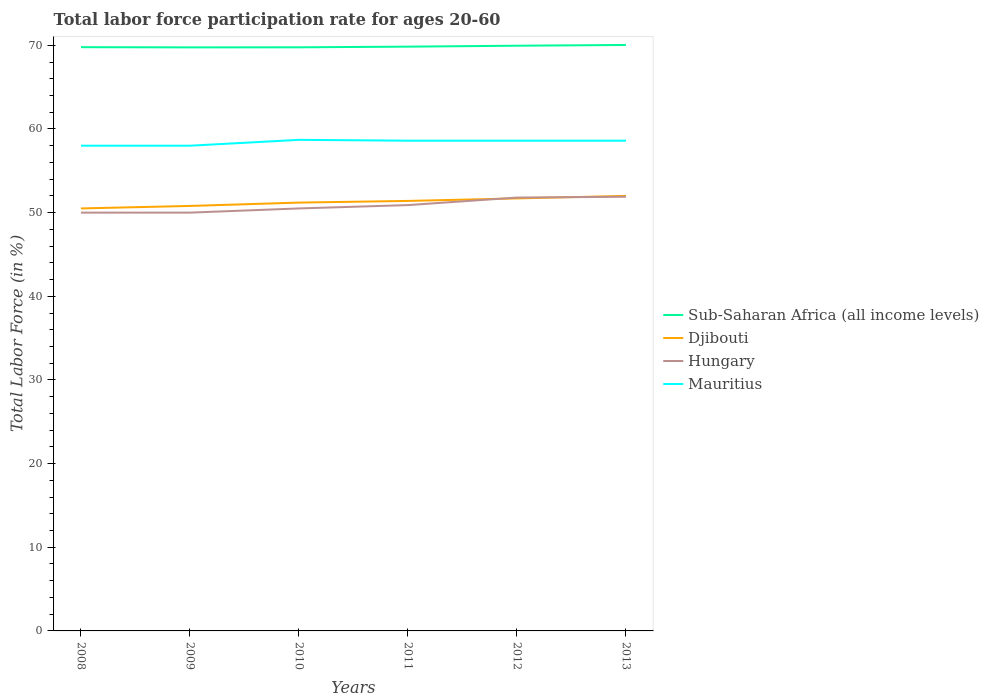How many different coloured lines are there?
Your answer should be compact. 4. Does the line corresponding to Mauritius intersect with the line corresponding to Hungary?
Give a very brief answer. No. Is the number of lines equal to the number of legend labels?
Provide a short and direct response. Yes. Across all years, what is the maximum labor force participation rate in Mauritius?
Give a very brief answer. 58. In which year was the labor force participation rate in Sub-Saharan Africa (all income levels) maximum?
Keep it short and to the point. 2009. What is the total labor force participation rate in Djibouti in the graph?
Provide a short and direct response. -0.6. What is the difference between the highest and the second highest labor force participation rate in Mauritius?
Provide a succinct answer. 0.7. What is the difference between the highest and the lowest labor force participation rate in Mauritius?
Ensure brevity in your answer.  4. How many lines are there?
Make the answer very short. 4. How many years are there in the graph?
Keep it short and to the point. 6. Are the values on the major ticks of Y-axis written in scientific E-notation?
Provide a succinct answer. No. Does the graph contain any zero values?
Offer a terse response. No. Where does the legend appear in the graph?
Offer a terse response. Center right. How many legend labels are there?
Give a very brief answer. 4. How are the legend labels stacked?
Your answer should be compact. Vertical. What is the title of the graph?
Your answer should be compact. Total labor force participation rate for ages 20-60. What is the label or title of the X-axis?
Offer a terse response. Years. What is the label or title of the Y-axis?
Make the answer very short. Total Labor Force (in %). What is the Total Labor Force (in %) in Sub-Saharan Africa (all income levels) in 2008?
Your response must be concise. 69.78. What is the Total Labor Force (in %) of Djibouti in 2008?
Make the answer very short. 50.5. What is the Total Labor Force (in %) of Mauritius in 2008?
Offer a very short reply. 58. What is the Total Labor Force (in %) in Sub-Saharan Africa (all income levels) in 2009?
Offer a very short reply. 69.75. What is the Total Labor Force (in %) in Djibouti in 2009?
Your answer should be compact. 50.8. What is the Total Labor Force (in %) of Mauritius in 2009?
Offer a very short reply. 58. What is the Total Labor Force (in %) in Sub-Saharan Africa (all income levels) in 2010?
Ensure brevity in your answer.  69.76. What is the Total Labor Force (in %) of Djibouti in 2010?
Make the answer very short. 51.2. What is the Total Labor Force (in %) in Hungary in 2010?
Keep it short and to the point. 50.5. What is the Total Labor Force (in %) in Mauritius in 2010?
Provide a succinct answer. 58.7. What is the Total Labor Force (in %) of Sub-Saharan Africa (all income levels) in 2011?
Your response must be concise. 69.84. What is the Total Labor Force (in %) of Djibouti in 2011?
Make the answer very short. 51.4. What is the Total Labor Force (in %) in Hungary in 2011?
Give a very brief answer. 50.9. What is the Total Labor Force (in %) of Mauritius in 2011?
Offer a very short reply. 58.6. What is the Total Labor Force (in %) in Sub-Saharan Africa (all income levels) in 2012?
Give a very brief answer. 69.95. What is the Total Labor Force (in %) of Djibouti in 2012?
Make the answer very short. 51.7. What is the Total Labor Force (in %) of Hungary in 2012?
Keep it short and to the point. 51.8. What is the Total Labor Force (in %) of Mauritius in 2012?
Keep it short and to the point. 58.6. What is the Total Labor Force (in %) in Sub-Saharan Africa (all income levels) in 2013?
Your answer should be compact. 70.04. What is the Total Labor Force (in %) in Djibouti in 2013?
Offer a terse response. 52. What is the Total Labor Force (in %) in Hungary in 2013?
Offer a terse response. 51.9. What is the Total Labor Force (in %) of Mauritius in 2013?
Keep it short and to the point. 58.6. Across all years, what is the maximum Total Labor Force (in %) of Sub-Saharan Africa (all income levels)?
Provide a succinct answer. 70.04. Across all years, what is the maximum Total Labor Force (in %) in Djibouti?
Your answer should be compact. 52. Across all years, what is the maximum Total Labor Force (in %) in Hungary?
Your answer should be compact. 51.9. Across all years, what is the maximum Total Labor Force (in %) in Mauritius?
Keep it short and to the point. 58.7. Across all years, what is the minimum Total Labor Force (in %) in Sub-Saharan Africa (all income levels)?
Your response must be concise. 69.75. Across all years, what is the minimum Total Labor Force (in %) of Djibouti?
Your answer should be compact. 50.5. Across all years, what is the minimum Total Labor Force (in %) in Mauritius?
Offer a very short reply. 58. What is the total Total Labor Force (in %) of Sub-Saharan Africa (all income levels) in the graph?
Provide a succinct answer. 419.12. What is the total Total Labor Force (in %) in Djibouti in the graph?
Offer a very short reply. 307.6. What is the total Total Labor Force (in %) of Hungary in the graph?
Provide a short and direct response. 305.1. What is the total Total Labor Force (in %) of Mauritius in the graph?
Your answer should be compact. 350.5. What is the difference between the Total Labor Force (in %) of Sub-Saharan Africa (all income levels) in 2008 and that in 2009?
Ensure brevity in your answer.  0.02. What is the difference between the Total Labor Force (in %) of Djibouti in 2008 and that in 2009?
Offer a very short reply. -0.3. What is the difference between the Total Labor Force (in %) in Sub-Saharan Africa (all income levels) in 2008 and that in 2010?
Give a very brief answer. 0.02. What is the difference between the Total Labor Force (in %) in Djibouti in 2008 and that in 2010?
Your answer should be compact. -0.7. What is the difference between the Total Labor Force (in %) of Hungary in 2008 and that in 2010?
Offer a terse response. -0.5. What is the difference between the Total Labor Force (in %) in Sub-Saharan Africa (all income levels) in 2008 and that in 2011?
Your answer should be compact. -0.06. What is the difference between the Total Labor Force (in %) of Sub-Saharan Africa (all income levels) in 2008 and that in 2012?
Provide a short and direct response. -0.17. What is the difference between the Total Labor Force (in %) of Hungary in 2008 and that in 2012?
Offer a terse response. -1.8. What is the difference between the Total Labor Force (in %) of Mauritius in 2008 and that in 2012?
Offer a terse response. -0.6. What is the difference between the Total Labor Force (in %) in Sub-Saharan Africa (all income levels) in 2008 and that in 2013?
Offer a very short reply. -0.27. What is the difference between the Total Labor Force (in %) in Hungary in 2008 and that in 2013?
Make the answer very short. -1.9. What is the difference between the Total Labor Force (in %) of Mauritius in 2008 and that in 2013?
Ensure brevity in your answer.  -0.6. What is the difference between the Total Labor Force (in %) in Sub-Saharan Africa (all income levels) in 2009 and that in 2010?
Provide a short and direct response. -0.01. What is the difference between the Total Labor Force (in %) in Hungary in 2009 and that in 2010?
Give a very brief answer. -0.5. What is the difference between the Total Labor Force (in %) in Sub-Saharan Africa (all income levels) in 2009 and that in 2011?
Your response must be concise. -0.09. What is the difference between the Total Labor Force (in %) in Sub-Saharan Africa (all income levels) in 2009 and that in 2012?
Make the answer very short. -0.2. What is the difference between the Total Labor Force (in %) of Mauritius in 2009 and that in 2012?
Give a very brief answer. -0.6. What is the difference between the Total Labor Force (in %) of Sub-Saharan Africa (all income levels) in 2009 and that in 2013?
Offer a terse response. -0.29. What is the difference between the Total Labor Force (in %) in Djibouti in 2009 and that in 2013?
Make the answer very short. -1.2. What is the difference between the Total Labor Force (in %) of Mauritius in 2009 and that in 2013?
Offer a terse response. -0.6. What is the difference between the Total Labor Force (in %) of Sub-Saharan Africa (all income levels) in 2010 and that in 2011?
Offer a terse response. -0.08. What is the difference between the Total Labor Force (in %) of Sub-Saharan Africa (all income levels) in 2010 and that in 2012?
Offer a very short reply. -0.19. What is the difference between the Total Labor Force (in %) of Djibouti in 2010 and that in 2012?
Make the answer very short. -0.5. What is the difference between the Total Labor Force (in %) of Hungary in 2010 and that in 2012?
Provide a short and direct response. -1.3. What is the difference between the Total Labor Force (in %) in Sub-Saharan Africa (all income levels) in 2010 and that in 2013?
Offer a terse response. -0.28. What is the difference between the Total Labor Force (in %) of Djibouti in 2010 and that in 2013?
Provide a short and direct response. -0.8. What is the difference between the Total Labor Force (in %) in Hungary in 2010 and that in 2013?
Offer a very short reply. -1.4. What is the difference between the Total Labor Force (in %) in Mauritius in 2010 and that in 2013?
Your answer should be very brief. 0.1. What is the difference between the Total Labor Force (in %) in Sub-Saharan Africa (all income levels) in 2011 and that in 2012?
Give a very brief answer. -0.11. What is the difference between the Total Labor Force (in %) in Hungary in 2011 and that in 2012?
Make the answer very short. -0.9. What is the difference between the Total Labor Force (in %) in Sub-Saharan Africa (all income levels) in 2011 and that in 2013?
Your response must be concise. -0.2. What is the difference between the Total Labor Force (in %) of Sub-Saharan Africa (all income levels) in 2012 and that in 2013?
Your answer should be compact. -0.09. What is the difference between the Total Labor Force (in %) in Mauritius in 2012 and that in 2013?
Provide a succinct answer. 0. What is the difference between the Total Labor Force (in %) of Sub-Saharan Africa (all income levels) in 2008 and the Total Labor Force (in %) of Djibouti in 2009?
Give a very brief answer. 18.98. What is the difference between the Total Labor Force (in %) of Sub-Saharan Africa (all income levels) in 2008 and the Total Labor Force (in %) of Hungary in 2009?
Ensure brevity in your answer.  19.78. What is the difference between the Total Labor Force (in %) of Sub-Saharan Africa (all income levels) in 2008 and the Total Labor Force (in %) of Mauritius in 2009?
Offer a very short reply. 11.78. What is the difference between the Total Labor Force (in %) of Djibouti in 2008 and the Total Labor Force (in %) of Mauritius in 2009?
Keep it short and to the point. -7.5. What is the difference between the Total Labor Force (in %) of Hungary in 2008 and the Total Labor Force (in %) of Mauritius in 2009?
Give a very brief answer. -8. What is the difference between the Total Labor Force (in %) of Sub-Saharan Africa (all income levels) in 2008 and the Total Labor Force (in %) of Djibouti in 2010?
Your response must be concise. 18.58. What is the difference between the Total Labor Force (in %) in Sub-Saharan Africa (all income levels) in 2008 and the Total Labor Force (in %) in Hungary in 2010?
Make the answer very short. 19.28. What is the difference between the Total Labor Force (in %) of Sub-Saharan Africa (all income levels) in 2008 and the Total Labor Force (in %) of Mauritius in 2010?
Offer a very short reply. 11.08. What is the difference between the Total Labor Force (in %) in Sub-Saharan Africa (all income levels) in 2008 and the Total Labor Force (in %) in Djibouti in 2011?
Your answer should be very brief. 18.38. What is the difference between the Total Labor Force (in %) of Sub-Saharan Africa (all income levels) in 2008 and the Total Labor Force (in %) of Hungary in 2011?
Provide a succinct answer. 18.88. What is the difference between the Total Labor Force (in %) in Sub-Saharan Africa (all income levels) in 2008 and the Total Labor Force (in %) in Mauritius in 2011?
Offer a terse response. 11.18. What is the difference between the Total Labor Force (in %) in Hungary in 2008 and the Total Labor Force (in %) in Mauritius in 2011?
Provide a short and direct response. -8.6. What is the difference between the Total Labor Force (in %) in Sub-Saharan Africa (all income levels) in 2008 and the Total Labor Force (in %) in Djibouti in 2012?
Make the answer very short. 18.08. What is the difference between the Total Labor Force (in %) in Sub-Saharan Africa (all income levels) in 2008 and the Total Labor Force (in %) in Hungary in 2012?
Your answer should be very brief. 17.98. What is the difference between the Total Labor Force (in %) of Sub-Saharan Africa (all income levels) in 2008 and the Total Labor Force (in %) of Mauritius in 2012?
Keep it short and to the point. 11.18. What is the difference between the Total Labor Force (in %) in Djibouti in 2008 and the Total Labor Force (in %) in Hungary in 2012?
Offer a very short reply. -1.3. What is the difference between the Total Labor Force (in %) of Hungary in 2008 and the Total Labor Force (in %) of Mauritius in 2012?
Give a very brief answer. -8.6. What is the difference between the Total Labor Force (in %) of Sub-Saharan Africa (all income levels) in 2008 and the Total Labor Force (in %) of Djibouti in 2013?
Your answer should be very brief. 17.78. What is the difference between the Total Labor Force (in %) in Sub-Saharan Africa (all income levels) in 2008 and the Total Labor Force (in %) in Hungary in 2013?
Make the answer very short. 17.88. What is the difference between the Total Labor Force (in %) in Sub-Saharan Africa (all income levels) in 2008 and the Total Labor Force (in %) in Mauritius in 2013?
Give a very brief answer. 11.18. What is the difference between the Total Labor Force (in %) of Djibouti in 2008 and the Total Labor Force (in %) of Mauritius in 2013?
Your answer should be compact. -8.1. What is the difference between the Total Labor Force (in %) of Hungary in 2008 and the Total Labor Force (in %) of Mauritius in 2013?
Your answer should be compact. -8.6. What is the difference between the Total Labor Force (in %) of Sub-Saharan Africa (all income levels) in 2009 and the Total Labor Force (in %) of Djibouti in 2010?
Your answer should be compact. 18.55. What is the difference between the Total Labor Force (in %) of Sub-Saharan Africa (all income levels) in 2009 and the Total Labor Force (in %) of Hungary in 2010?
Make the answer very short. 19.25. What is the difference between the Total Labor Force (in %) of Sub-Saharan Africa (all income levels) in 2009 and the Total Labor Force (in %) of Mauritius in 2010?
Your response must be concise. 11.05. What is the difference between the Total Labor Force (in %) of Djibouti in 2009 and the Total Labor Force (in %) of Hungary in 2010?
Ensure brevity in your answer.  0.3. What is the difference between the Total Labor Force (in %) of Djibouti in 2009 and the Total Labor Force (in %) of Mauritius in 2010?
Your response must be concise. -7.9. What is the difference between the Total Labor Force (in %) of Sub-Saharan Africa (all income levels) in 2009 and the Total Labor Force (in %) of Djibouti in 2011?
Make the answer very short. 18.35. What is the difference between the Total Labor Force (in %) in Sub-Saharan Africa (all income levels) in 2009 and the Total Labor Force (in %) in Hungary in 2011?
Provide a short and direct response. 18.85. What is the difference between the Total Labor Force (in %) of Sub-Saharan Africa (all income levels) in 2009 and the Total Labor Force (in %) of Mauritius in 2011?
Keep it short and to the point. 11.15. What is the difference between the Total Labor Force (in %) of Djibouti in 2009 and the Total Labor Force (in %) of Mauritius in 2011?
Give a very brief answer. -7.8. What is the difference between the Total Labor Force (in %) of Sub-Saharan Africa (all income levels) in 2009 and the Total Labor Force (in %) of Djibouti in 2012?
Make the answer very short. 18.05. What is the difference between the Total Labor Force (in %) of Sub-Saharan Africa (all income levels) in 2009 and the Total Labor Force (in %) of Hungary in 2012?
Make the answer very short. 17.95. What is the difference between the Total Labor Force (in %) of Sub-Saharan Africa (all income levels) in 2009 and the Total Labor Force (in %) of Mauritius in 2012?
Your response must be concise. 11.15. What is the difference between the Total Labor Force (in %) in Hungary in 2009 and the Total Labor Force (in %) in Mauritius in 2012?
Provide a short and direct response. -8.6. What is the difference between the Total Labor Force (in %) of Sub-Saharan Africa (all income levels) in 2009 and the Total Labor Force (in %) of Djibouti in 2013?
Your answer should be very brief. 17.75. What is the difference between the Total Labor Force (in %) of Sub-Saharan Africa (all income levels) in 2009 and the Total Labor Force (in %) of Hungary in 2013?
Offer a terse response. 17.85. What is the difference between the Total Labor Force (in %) of Sub-Saharan Africa (all income levels) in 2009 and the Total Labor Force (in %) of Mauritius in 2013?
Provide a succinct answer. 11.15. What is the difference between the Total Labor Force (in %) in Djibouti in 2009 and the Total Labor Force (in %) in Hungary in 2013?
Offer a terse response. -1.1. What is the difference between the Total Labor Force (in %) of Djibouti in 2009 and the Total Labor Force (in %) of Mauritius in 2013?
Give a very brief answer. -7.8. What is the difference between the Total Labor Force (in %) in Hungary in 2009 and the Total Labor Force (in %) in Mauritius in 2013?
Make the answer very short. -8.6. What is the difference between the Total Labor Force (in %) in Sub-Saharan Africa (all income levels) in 2010 and the Total Labor Force (in %) in Djibouti in 2011?
Provide a succinct answer. 18.36. What is the difference between the Total Labor Force (in %) in Sub-Saharan Africa (all income levels) in 2010 and the Total Labor Force (in %) in Hungary in 2011?
Give a very brief answer. 18.86. What is the difference between the Total Labor Force (in %) of Sub-Saharan Africa (all income levels) in 2010 and the Total Labor Force (in %) of Mauritius in 2011?
Your answer should be very brief. 11.16. What is the difference between the Total Labor Force (in %) in Djibouti in 2010 and the Total Labor Force (in %) in Mauritius in 2011?
Give a very brief answer. -7.4. What is the difference between the Total Labor Force (in %) of Hungary in 2010 and the Total Labor Force (in %) of Mauritius in 2011?
Offer a very short reply. -8.1. What is the difference between the Total Labor Force (in %) of Sub-Saharan Africa (all income levels) in 2010 and the Total Labor Force (in %) of Djibouti in 2012?
Keep it short and to the point. 18.06. What is the difference between the Total Labor Force (in %) in Sub-Saharan Africa (all income levels) in 2010 and the Total Labor Force (in %) in Hungary in 2012?
Keep it short and to the point. 17.96. What is the difference between the Total Labor Force (in %) of Sub-Saharan Africa (all income levels) in 2010 and the Total Labor Force (in %) of Mauritius in 2012?
Give a very brief answer. 11.16. What is the difference between the Total Labor Force (in %) in Djibouti in 2010 and the Total Labor Force (in %) in Hungary in 2012?
Keep it short and to the point. -0.6. What is the difference between the Total Labor Force (in %) in Hungary in 2010 and the Total Labor Force (in %) in Mauritius in 2012?
Your response must be concise. -8.1. What is the difference between the Total Labor Force (in %) of Sub-Saharan Africa (all income levels) in 2010 and the Total Labor Force (in %) of Djibouti in 2013?
Your answer should be very brief. 17.76. What is the difference between the Total Labor Force (in %) in Sub-Saharan Africa (all income levels) in 2010 and the Total Labor Force (in %) in Hungary in 2013?
Provide a succinct answer. 17.86. What is the difference between the Total Labor Force (in %) in Sub-Saharan Africa (all income levels) in 2010 and the Total Labor Force (in %) in Mauritius in 2013?
Your answer should be compact. 11.16. What is the difference between the Total Labor Force (in %) of Djibouti in 2010 and the Total Labor Force (in %) of Mauritius in 2013?
Your response must be concise. -7.4. What is the difference between the Total Labor Force (in %) in Sub-Saharan Africa (all income levels) in 2011 and the Total Labor Force (in %) in Djibouti in 2012?
Give a very brief answer. 18.14. What is the difference between the Total Labor Force (in %) in Sub-Saharan Africa (all income levels) in 2011 and the Total Labor Force (in %) in Hungary in 2012?
Provide a short and direct response. 18.04. What is the difference between the Total Labor Force (in %) of Sub-Saharan Africa (all income levels) in 2011 and the Total Labor Force (in %) of Mauritius in 2012?
Give a very brief answer. 11.24. What is the difference between the Total Labor Force (in %) in Djibouti in 2011 and the Total Labor Force (in %) in Mauritius in 2012?
Your response must be concise. -7.2. What is the difference between the Total Labor Force (in %) of Hungary in 2011 and the Total Labor Force (in %) of Mauritius in 2012?
Make the answer very short. -7.7. What is the difference between the Total Labor Force (in %) in Sub-Saharan Africa (all income levels) in 2011 and the Total Labor Force (in %) in Djibouti in 2013?
Provide a short and direct response. 17.84. What is the difference between the Total Labor Force (in %) of Sub-Saharan Africa (all income levels) in 2011 and the Total Labor Force (in %) of Hungary in 2013?
Provide a succinct answer. 17.94. What is the difference between the Total Labor Force (in %) of Sub-Saharan Africa (all income levels) in 2011 and the Total Labor Force (in %) of Mauritius in 2013?
Give a very brief answer. 11.24. What is the difference between the Total Labor Force (in %) in Djibouti in 2011 and the Total Labor Force (in %) in Hungary in 2013?
Offer a very short reply. -0.5. What is the difference between the Total Labor Force (in %) in Djibouti in 2011 and the Total Labor Force (in %) in Mauritius in 2013?
Offer a very short reply. -7.2. What is the difference between the Total Labor Force (in %) in Hungary in 2011 and the Total Labor Force (in %) in Mauritius in 2013?
Keep it short and to the point. -7.7. What is the difference between the Total Labor Force (in %) of Sub-Saharan Africa (all income levels) in 2012 and the Total Labor Force (in %) of Djibouti in 2013?
Offer a very short reply. 17.95. What is the difference between the Total Labor Force (in %) in Sub-Saharan Africa (all income levels) in 2012 and the Total Labor Force (in %) in Hungary in 2013?
Offer a very short reply. 18.05. What is the difference between the Total Labor Force (in %) of Sub-Saharan Africa (all income levels) in 2012 and the Total Labor Force (in %) of Mauritius in 2013?
Make the answer very short. 11.35. What is the difference between the Total Labor Force (in %) of Djibouti in 2012 and the Total Labor Force (in %) of Hungary in 2013?
Offer a terse response. -0.2. What is the difference between the Total Labor Force (in %) in Hungary in 2012 and the Total Labor Force (in %) in Mauritius in 2013?
Offer a very short reply. -6.8. What is the average Total Labor Force (in %) of Sub-Saharan Africa (all income levels) per year?
Offer a very short reply. 69.85. What is the average Total Labor Force (in %) of Djibouti per year?
Your answer should be compact. 51.27. What is the average Total Labor Force (in %) of Hungary per year?
Ensure brevity in your answer.  50.85. What is the average Total Labor Force (in %) of Mauritius per year?
Provide a short and direct response. 58.42. In the year 2008, what is the difference between the Total Labor Force (in %) in Sub-Saharan Africa (all income levels) and Total Labor Force (in %) in Djibouti?
Provide a short and direct response. 19.28. In the year 2008, what is the difference between the Total Labor Force (in %) in Sub-Saharan Africa (all income levels) and Total Labor Force (in %) in Hungary?
Give a very brief answer. 19.78. In the year 2008, what is the difference between the Total Labor Force (in %) of Sub-Saharan Africa (all income levels) and Total Labor Force (in %) of Mauritius?
Your answer should be very brief. 11.78. In the year 2009, what is the difference between the Total Labor Force (in %) in Sub-Saharan Africa (all income levels) and Total Labor Force (in %) in Djibouti?
Provide a succinct answer. 18.95. In the year 2009, what is the difference between the Total Labor Force (in %) of Sub-Saharan Africa (all income levels) and Total Labor Force (in %) of Hungary?
Give a very brief answer. 19.75. In the year 2009, what is the difference between the Total Labor Force (in %) of Sub-Saharan Africa (all income levels) and Total Labor Force (in %) of Mauritius?
Offer a terse response. 11.75. In the year 2009, what is the difference between the Total Labor Force (in %) of Djibouti and Total Labor Force (in %) of Hungary?
Your answer should be compact. 0.8. In the year 2009, what is the difference between the Total Labor Force (in %) in Djibouti and Total Labor Force (in %) in Mauritius?
Give a very brief answer. -7.2. In the year 2009, what is the difference between the Total Labor Force (in %) of Hungary and Total Labor Force (in %) of Mauritius?
Make the answer very short. -8. In the year 2010, what is the difference between the Total Labor Force (in %) of Sub-Saharan Africa (all income levels) and Total Labor Force (in %) of Djibouti?
Provide a short and direct response. 18.56. In the year 2010, what is the difference between the Total Labor Force (in %) of Sub-Saharan Africa (all income levels) and Total Labor Force (in %) of Hungary?
Your answer should be very brief. 19.26. In the year 2010, what is the difference between the Total Labor Force (in %) of Sub-Saharan Africa (all income levels) and Total Labor Force (in %) of Mauritius?
Offer a terse response. 11.06. In the year 2011, what is the difference between the Total Labor Force (in %) of Sub-Saharan Africa (all income levels) and Total Labor Force (in %) of Djibouti?
Keep it short and to the point. 18.44. In the year 2011, what is the difference between the Total Labor Force (in %) in Sub-Saharan Africa (all income levels) and Total Labor Force (in %) in Hungary?
Offer a very short reply. 18.94. In the year 2011, what is the difference between the Total Labor Force (in %) in Sub-Saharan Africa (all income levels) and Total Labor Force (in %) in Mauritius?
Provide a succinct answer. 11.24. In the year 2012, what is the difference between the Total Labor Force (in %) of Sub-Saharan Africa (all income levels) and Total Labor Force (in %) of Djibouti?
Offer a terse response. 18.25. In the year 2012, what is the difference between the Total Labor Force (in %) in Sub-Saharan Africa (all income levels) and Total Labor Force (in %) in Hungary?
Provide a short and direct response. 18.15. In the year 2012, what is the difference between the Total Labor Force (in %) in Sub-Saharan Africa (all income levels) and Total Labor Force (in %) in Mauritius?
Ensure brevity in your answer.  11.35. In the year 2012, what is the difference between the Total Labor Force (in %) of Djibouti and Total Labor Force (in %) of Hungary?
Offer a terse response. -0.1. In the year 2013, what is the difference between the Total Labor Force (in %) of Sub-Saharan Africa (all income levels) and Total Labor Force (in %) of Djibouti?
Keep it short and to the point. 18.04. In the year 2013, what is the difference between the Total Labor Force (in %) in Sub-Saharan Africa (all income levels) and Total Labor Force (in %) in Hungary?
Provide a succinct answer. 18.14. In the year 2013, what is the difference between the Total Labor Force (in %) of Sub-Saharan Africa (all income levels) and Total Labor Force (in %) of Mauritius?
Provide a succinct answer. 11.44. In the year 2013, what is the difference between the Total Labor Force (in %) in Djibouti and Total Labor Force (in %) in Hungary?
Provide a short and direct response. 0.1. What is the ratio of the Total Labor Force (in %) in Hungary in 2008 to that in 2009?
Offer a very short reply. 1. What is the ratio of the Total Labor Force (in %) in Mauritius in 2008 to that in 2009?
Make the answer very short. 1. What is the ratio of the Total Labor Force (in %) of Djibouti in 2008 to that in 2010?
Your answer should be very brief. 0.99. What is the ratio of the Total Labor Force (in %) of Hungary in 2008 to that in 2010?
Offer a terse response. 0.99. What is the ratio of the Total Labor Force (in %) in Sub-Saharan Africa (all income levels) in 2008 to that in 2011?
Keep it short and to the point. 1. What is the ratio of the Total Labor Force (in %) in Djibouti in 2008 to that in 2011?
Your answer should be compact. 0.98. What is the ratio of the Total Labor Force (in %) of Hungary in 2008 to that in 2011?
Give a very brief answer. 0.98. What is the ratio of the Total Labor Force (in %) in Sub-Saharan Africa (all income levels) in 2008 to that in 2012?
Keep it short and to the point. 1. What is the ratio of the Total Labor Force (in %) of Djibouti in 2008 to that in 2012?
Your answer should be very brief. 0.98. What is the ratio of the Total Labor Force (in %) of Hungary in 2008 to that in 2012?
Your answer should be compact. 0.97. What is the ratio of the Total Labor Force (in %) of Sub-Saharan Africa (all income levels) in 2008 to that in 2013?
Provide a short and direct response. 1. What is the ratio of the Total Labor Force (in %) in Djibouti in 2008 to that in 2013?
Offer a terse response. 0.97. What is the ratio of the Total Labor Force (in %) in Hungary in 2008 to that in 2013?
Your response must be concise. 0.96. What is the ratio of the Total Labor Force (in %) of Sub-Saharan Africa (all income levels) in 2009 to that in 2010?
Your answer should be compact. 1. What is the ratio of the Total Labor Force (in %) in Djibouti in 2009 to that in 2010?
Give a very brief answer. 0.99. What is the ratio of the Total Labor Force (in %) of Hungary in 2009 to that in 2010?
Your answer should be very brief. 0.99. What is the ratio of the Total Labor Force (in %) of Sub-Saharan Africa (all income levels) in 2009 to that in 2011?
Your answer should be compact. 1. What is the ratio of the Total Labor Force (in %) of Djibouti in 2009 to that in 2011?
Ensure brevity in your answer.  0.99. What is the ratio of the Total Labor Force (in %) in Hungary in 2009 to that in 2011?
Your response must be concise. 0.98. What is the ratio of the Total Labor Force (in %) in Sub-Saharan Africa (all income levels) in 2009 to that in 2012?
Your answer should be compact. 1. What is the ratio of the Total Labor Force (in %) of Djibouti in 2009 to that in 2012?
Your response must be concise. 0.98. What is the ratio of the Total Labor Force (in %) of Hungary in 2009 to that in 2012?
Your answer should be very brief. 0.97. What is the ratio of the Total Labor Force (in %) in Djibouti in 2009 to that in 2013?
Your response must be concise. 0.98. What is the ratio of the Total Labor Force (in %) in Hungary in 2009 to that in 2013?
Make the answer very short. 0.96. What is the ratio of the Total Labor Force (in %) of Mauritius in 2009 to that in 2013?
Provide a short and direct response. 0.99. What is the ratio of the Total Labor Force (in %) in Mauritius in 2010 to that in 2011?
Make the answer very short. 1. What is the ratio of the Total Labor Force (in %) in Sub-Saharan Africa (all income levels) in 2010 to that in 2012?
Your answer should be very brief. 1. What is the ratio of the Total Labor Force (in %) in Djibouti in 2010 to that in 2012?
Your answer should be very brief. 0.99. What is the ratio of the Total Labor Force (in %) in Hungary in 2010 to that in 2012?
Your response must be concise. 0.97. What is the ratio of the Total Labor Force (in %) in Sub-Saharan Africa (all income levels) in 2010 to that in 2013?
Your answer should be very brief. 1. What is the ratio of the Total Labor Force (in %) of Djibouti in 2010 to that in 2013?
Offer a terse response. 0.98. What is the ratio of the Total Labor Force (in %) in Mauritius in 2010 to that in 2013?
Your response must be concise. 1. What is the ratio of the Total Labor Force (in %) in Djibouti in 2011 to that in 2012?
Offer a very short reply. 0.99. What is the ratio of the Total Labor Force (in %) in Hungary in 2011 to that in 2012?
Make the answer very short. 0.98. What is the ratio of the Total Labor Force (in %) in Mauritius in 2011 to that in 2012?
Your response must be concise. 1. What is the ratio of the Total Labor Force (in %) in Djibouti in 2011 to that in 2013?
Make the answer very short. 0.99. What is the ratio of the Total Labor Force (in %) of Hungary in 2011 to that in 2013?
Keep it short and to the point. 0.98. What is the ratio of the Total Labor Force (in %) of Djibouti in 2012 to that in 2013?
Your answer should be very brief. 0.99. What is the ratio of the Total Labor Force (in %) in Mauritius in 2012 to that in 2013?
Make the answer very short. 1. What is the difference between the highest and the second highest Total Labor Force (in %) of Sub-Saharan Africa (all income levels)?
Give a very brief answer. 0.09. What is the difference between the highest and the second highest Total Labor Force (in %) in Djibouti?
Give a very brief answer. 0.3. What is the difference between the highest and the lowest Total Labor Force (in %) of Sub-Saharan Africa (all income levels)?
Ensure brevity in your answer.  0.29. What is the difference between the highest and the lowest Total Labor Force (in %) in Djibouti?
Your answer should be very brief. 1.5. What is the difference between the highest and the lowest Total Labor Force (in %) in Hungary?
Provide a succinct answer. 1.9. 